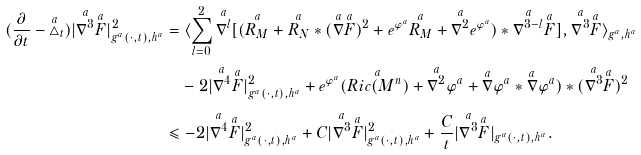<formula> <loc_0><loc_0><loc_500><loc_500>( \frac { \partial } { \partial t } - \overset { a } { \triangle } _ { t } ) | \overset { a } { \nabla ^ { 3 } } \overset { a } { F } | ^ { 2 } _ { g ^ { a } ( \cdot , t ) , h ^ { a } } & = \langle \sum _ { l = 0 } ^ { 2 } \overset { a } { \nabla ^ { l } } [ ( \overset { a } { R _ { M } } + \overset { a } { R _ { N } } \ast ( \overset { a } { \nabla } \overset { a } { F } ) ^ { 2 } + e ^ { \varphi ^ { a } } \overset { a } { R _ { M } } + \overset { a } { \nabla ^ { 2 } } e ^ { \varphi ^ { a } } ) \ast \overset { a } { \nabla ^ { 3 - l } } \overset { a } { F } ] , \overset { a } { \nabla ^ { 3 } } \overset { a } { F } \rangle _ { g ^ { a } , h ^ { a } } \\ & \quad - 2 | \overset { a } { \nabla ^ { 4 } } \overset { a } { F } | ^ { 2 } _ { g ^ { a } ( \cdot , t ) , h ^ { a } } + e ^ { \varphi ^ { a } } ( \overset { a } { R i c ( M ^ { n } ) } + \overset { a } { \nabla ^ { 2 } } \varphi ^ { a } + \overset { a } { \nabla } \varphi ^ { a } \ast \overset { a } { \nabla } \varphi ^ { a } ) \ast ( \overset { a } { \nabla ^ { 3 } } \overset { a } { F } ) ^ { 2 } \\ & \leqslant - 2 | \overset { a } { \nabla ^ { 4 } } \overset { a } { F } | ^ { 2 } _ { g ^ { a } ( \cdot , t ) , h ^ { a } } + C | \overset { a } { \nabla ^ { 3 } } \overset { a } { F } | ^ { 2 } _ { g ^ { a } ( \cdot , t ) , h ^ { a } } + \frac { C } { t } | \overset { a } { \nabla ^ { 3 } } \overset { a } { F } | _ { g ^ { a } ( \cdot , t ) , h ^ { a } } .</formula> 